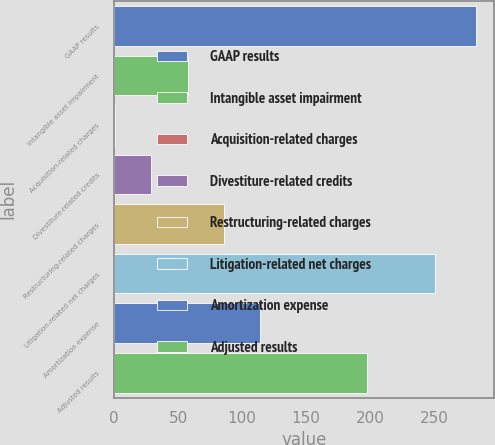<chart> <loc_0><loc_0><loc_500><loc_500><bar_chart><fcel>GAAP results<fcel>Intangible asset impairment<fcel>Acquisition-related charges<fcel>Divestiture-related credits<fcel>Restructuring-related charges<fcel>Litigation-related net charges<fcel>Amortization expense<fcel>Adjusted results<nl><fcel>283<fcel>57.4<fcel>1<fcel>29.2<fcel>85.6<fcel>251<fcel>113.8<fcel>198<nl></chart> 